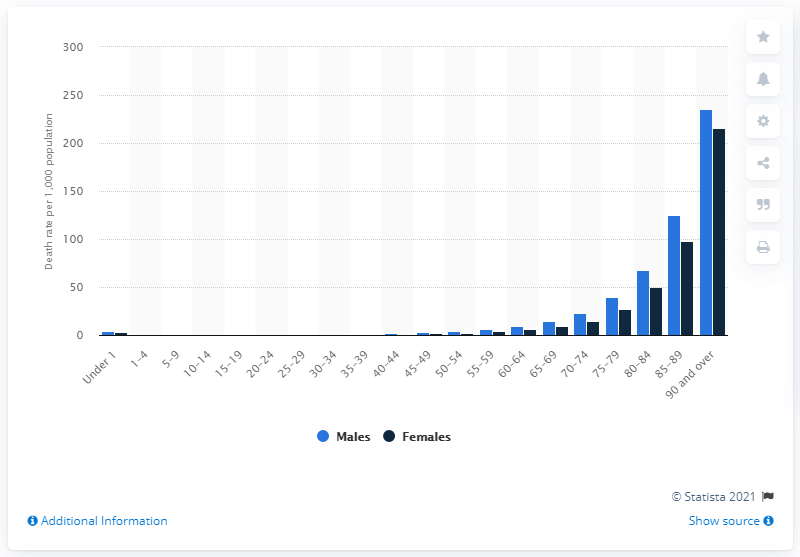Draw attention to some important aspects in this diagram. In 2018, the age-specific death rate for females was 215.2 per 100,000 population. In 2018, the age-specific death rate for males aged 90 or over was 235.1 deaths per 100,000 individuals in that age group. 